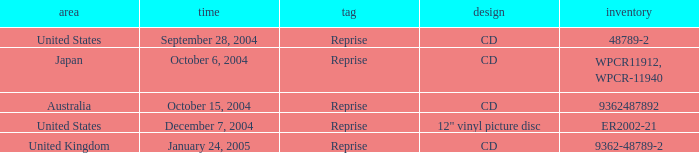Name the october 15, 2004 catalogue 9362487892.0. 